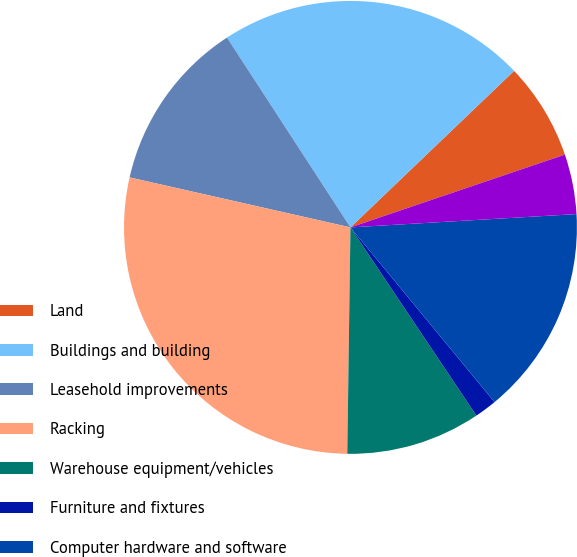<chart> <loc_0><loc_0><loc_500><loc_500><pie_chart><fcel>Land<fcel>Buildings and building<fcel>Leasehold improvements<fcel>Racking<fcel>Warehouse equipment/vehicles<fcel>Furniture and fixtures<fcel>Computer hardware and software<fcel>Construction in progress<nl><fcel>6.94%<fcel>22.03%<fcel>12.28%<fcel>28.32%<fcel>9.61%<fcel>1.59%<fcel>14.96%<fcel>4.27%<nl></chart> 